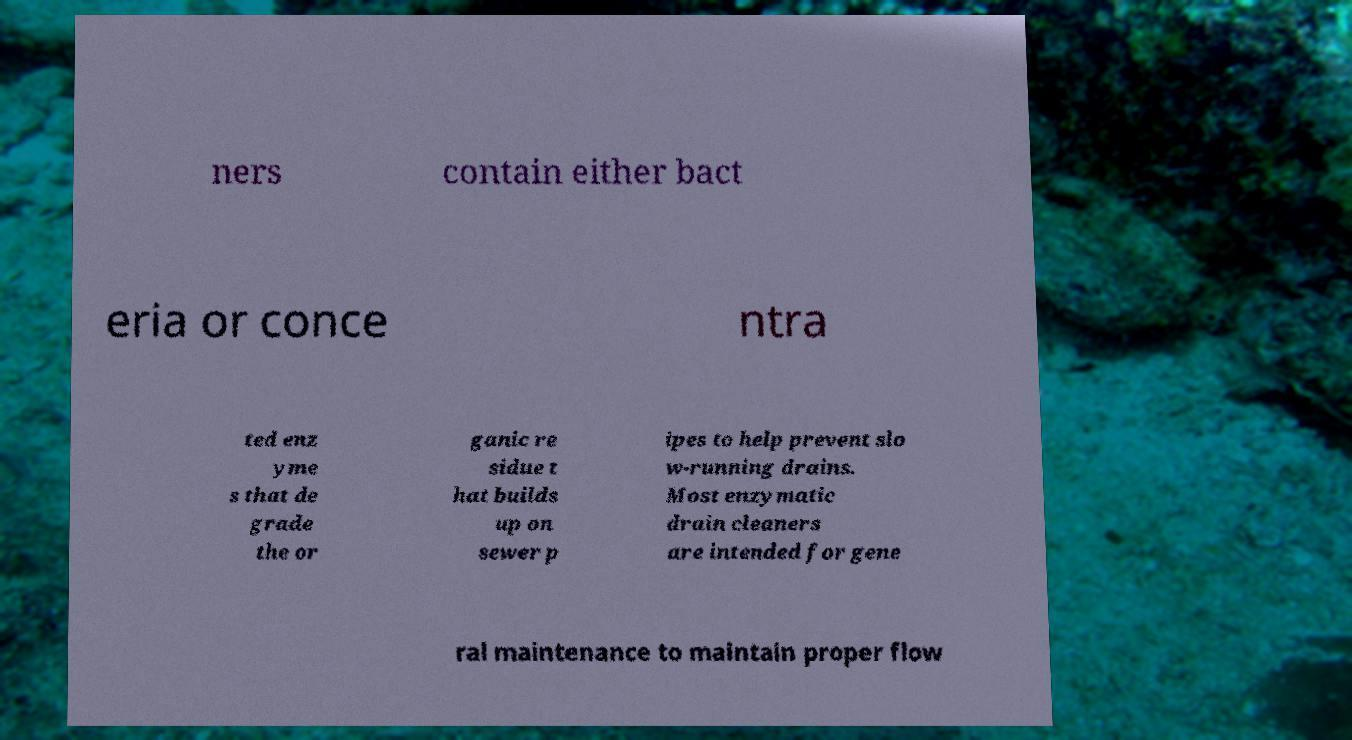Please identify and transcribe the text found in this image. ners contain either bact eria or conce ntra ted enz yme s that de grade the or ganic re sidue t hat builds up on sewer p ipes to help prevent slo w-running drains. Most enzymatic drain cleaners are intended for gene ral maintenance to maintain proper flow 